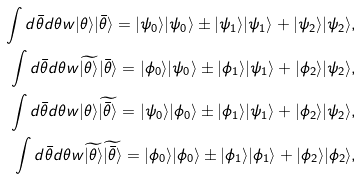Convert formula to latex. <formula><loc_0><loc_0><loc_500><loc_500>\int d \bar { \theta } d \theta w | \theta \rangle | \bar { \theta } \rangle = | \psi _ { 0 } \rangle | \psi _ { 0 } \rangle \pm | \psi _ { 1 } \rangle | \psi _ { 1 } \rangle + | \psi _ { 2 } \rangle | \psi _ { 2 } \rangle , \\ \int d \bar { \theta } d \theta w \widetilde { | \theta \rangle } | \bar { \theta } \rangle = | \phi _ { 0 } \rangle | \psi _ { 0 } \rangle \pm | \phi _ { 1 } \rangle | \psi _ { 1 } \rangle + | \phi _ { 2 } \rangle | \psi _ { 2 } \rangle , \\ \int d \bar { \theta } d \theta w | \theta \rangle \widetilde { | \bar { \theta } \rangle } = | \psi _ { 0 } \rangle | \phi _ { 0 } \rangle \pm | \phi _ { 1 } \rangle | \psi _ { 1 } \rangle + | \phi _ { 2 } \rangle | \psi _ { 2 } \rangle , \\ \int d \bar { \theta } d \theta w \widetilde { | \theta \rangle } \widetilde { | \bar { \theta } \rangle } = | \phi _ { 0 } \rangle | \phi _ { 0 } \rangle \pm | \phi _ { 1 } \rangle | \phi _ { 1 } \rangle + | \phi _ { 2 } \rangle | \phi _ { 2 } \rangle ,</formula> 